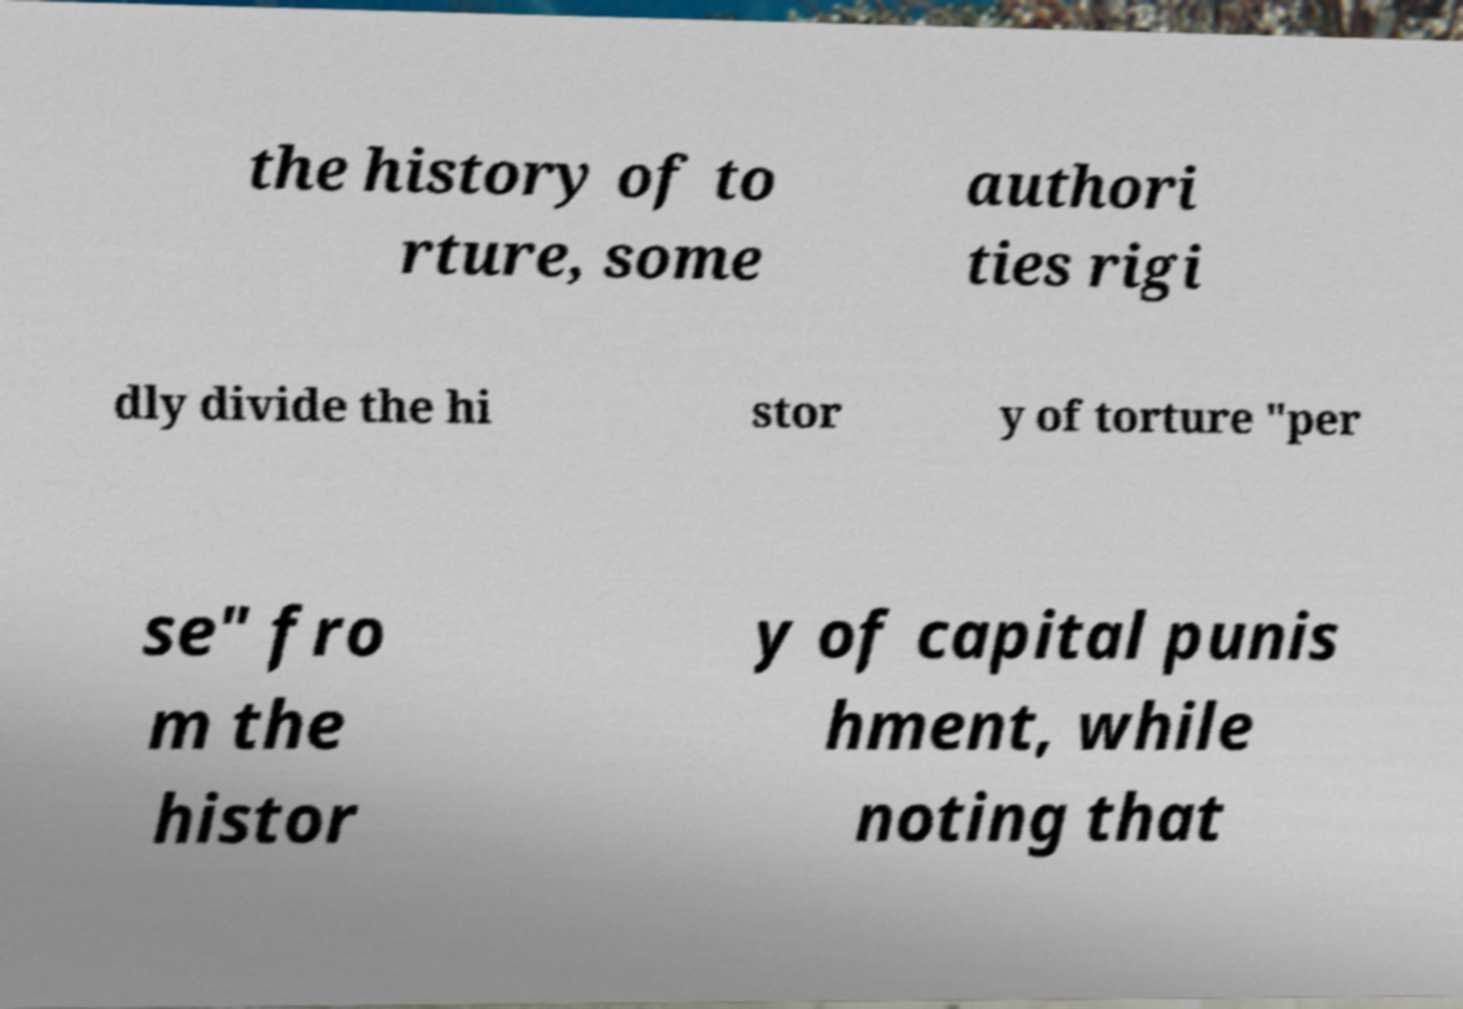There's text embedded in this image that I need extracted. Can you transcribe it verbatim? the history of to rture, some authori ties rigi dly divide the hi stor y of torture "per se" fro m the histor y of capital punis hment, while noting that 